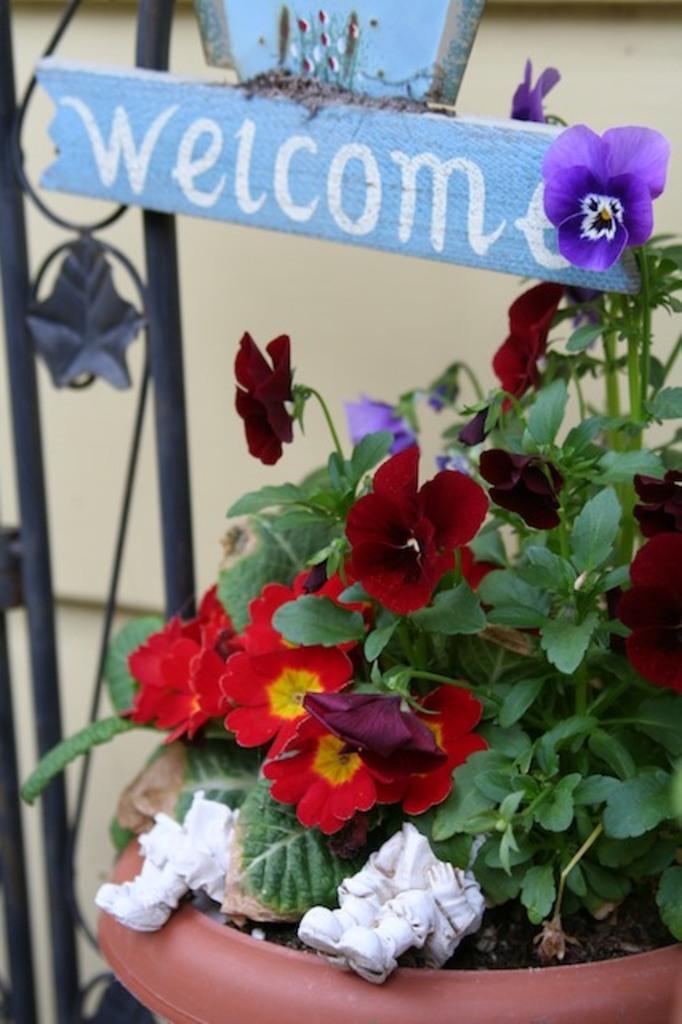In one or two sentences, can you explain what this image depicts? In this image there is a metal object on the left corner. There is a potted with flowers and green colored leaves on the right corner. There is a wooden board with text at the top. 